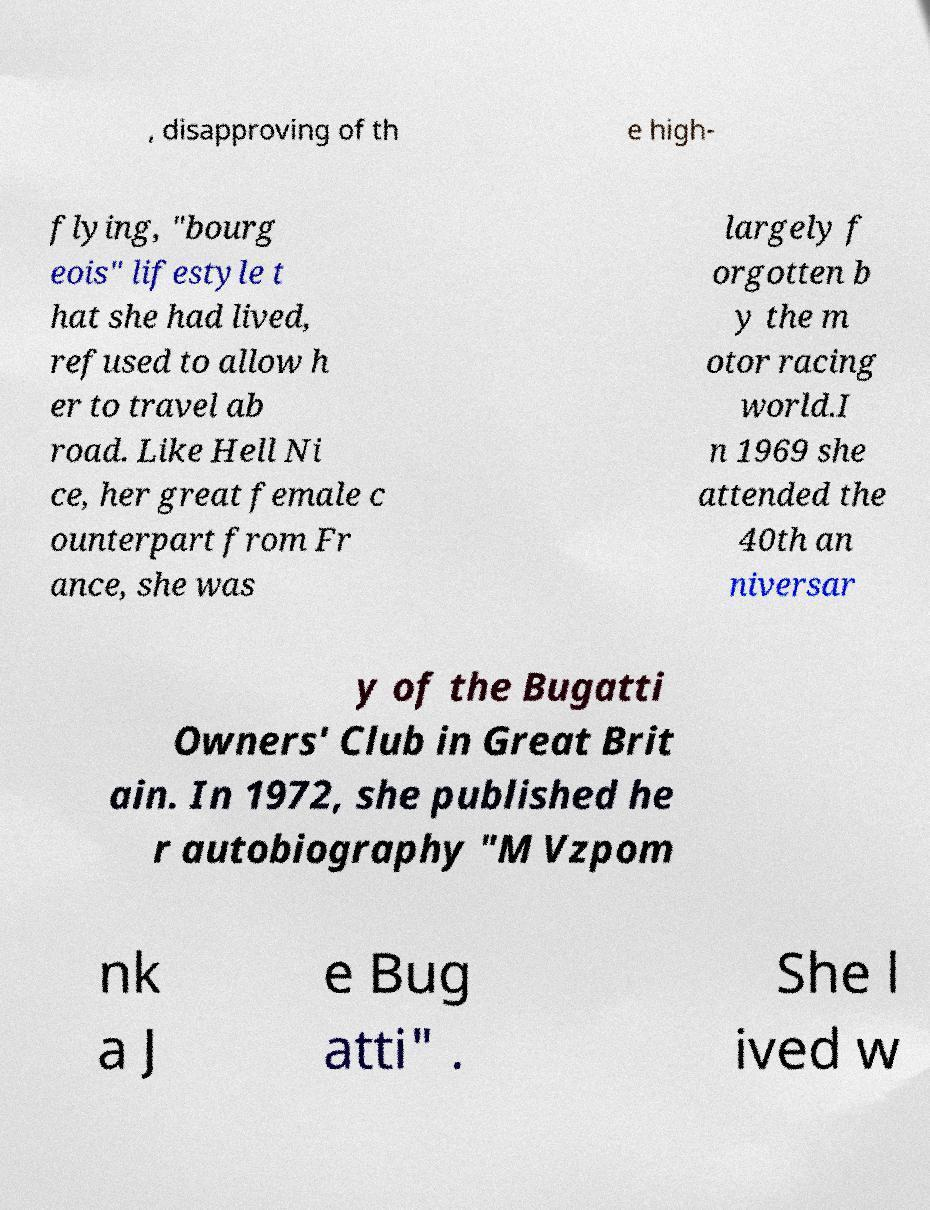Please identify and transcribe the text found in this image. , disapproving of th e high- flying, "bourg eois" lifestyle t hat she had lived, refused to allow h er to travel ab road. Like Hell Ni ce, her great female c ounterpart from Fr ance, she was largely f orgotten b y the m otor racing world.I n 1969 she attended the 40th an niversar y of the Bugatti Owners' Club in Great Brit ain. In 1972, she published he r autobiography "M Vzpom nk a J e Bug atti" . She l ived w 